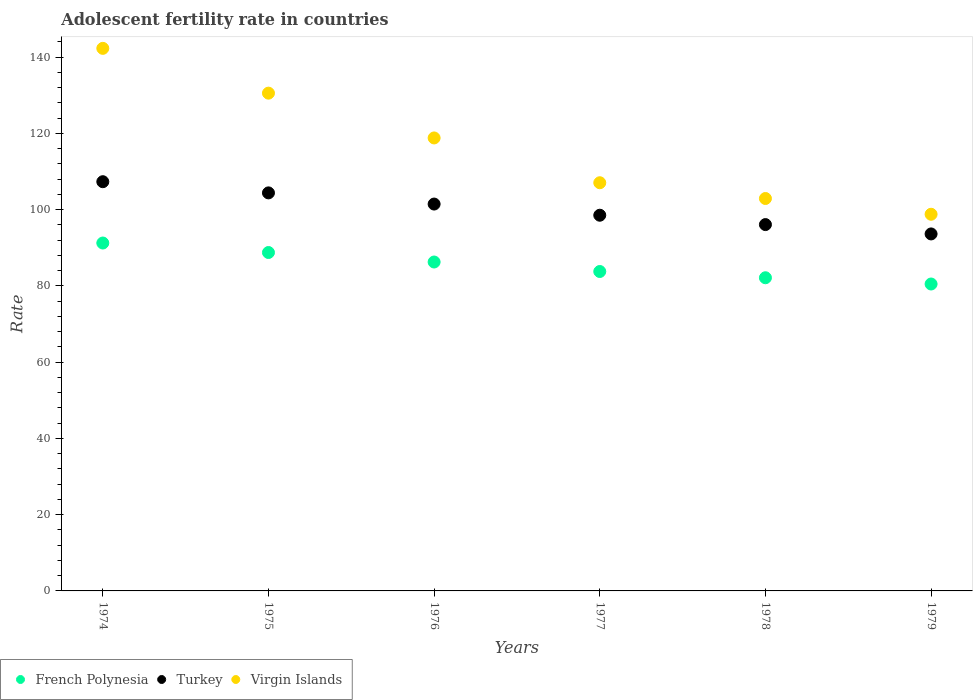What is the adolescent fertility rate in French Polynesia in 1976?
Your answer should be compact. 86.27. Across all years, what is the maximum adolescent fertility rate in French Polynesia?
Keep it short and to the point. 91.26. Across all years, what is the minimum adolescent fertility rate in Virgin Islands?
Provide a short and direct response. 98.8. In which year was the adolescent fertility rate in French Polynesia maximum?
Give a very brief answer. 1974. In which year was the adolescent fertility rate in Turkey minimum?
Keep it short and to the point. 1979. What is the total adolescent fertility rate in French Polynesia in the graph?
Your answer should be very brief. 512.73. What is the difference between the adolescent fertility rate in Turkey in 1975 and that in 1977?
Your answer should be very brief. 5.86. What is the difference between the adolescent fertility rate in French Polynesia in 1979 and the adolescent fertility rate in Turkey in 1977?
Make the answer very short. -18.04. What is the average adolescent fertility rate in French Polynesia per year?
Offer a very short reply. 85.45. In the year 1976, what is the difference between the adolescent fertility rate in Turkey and adolescent fertility rate in French Polynesia?
Give a very brief answer. 15.2. In how many years, is the adolescent fertility rate in Turkey greater than 8?
Offer a very short reply. 6. What is the ratio of the adolescent fertility rate in Virgin Islands in 1975 to that in 1976?
Ensure brevity in your answer.  1.1. Is the adolescent fertility rate in Turkey in 1975 less than that in 1976?
Provide a succinct answer. No. Is the difference between the adolescent fertility rate in Turkey in 1974 and 1975 greater than the difference between the adolescent fertility rate in French Polynesia in 1974 and 1975?
Give a very brief answer. Yes. What is the difference between the highest and the second highest adolescent fertility rate in French Polynesia?
Offer a very short reply. 2.49. What is the difference between the highest and the lowest adolescent fertility rate in Virgin Islands?
Offer a terse response. 43.52. In how many years, is the adolescent fertility rate in Virgin Islands greater than the average adolescent fertility rate in Virgin Islands taken over all years?
Your answer should be very brief. 3. Does the adolescent fertility rate in Virgin Islands monotonically increase over the years?
Your answer should be compact. No. Is the adolescent fertility rate in Turkey strictly greater than the adolescent fertility rate in Virgin Islands over the years?
Provide a succinct answer. No. Is the adolescent fertility rate in Virgin Islands strictly less than the adolescent fertility rate in Turkey over the years?
Make the answer very short. No. How many dotlines are there?
Ensure brevity in your answer.  3. Does the graph contain any zero values?
Your answer should be very brief. No. Where does the legend appear in the graph?
Ensure brevity in your answer.  Bottom left. How many legend labels are there?
Provide a short and direct response. 3. How are the legend labels stacked?
Provide a short and direct response. Horizontal. What is the title of the graph?
Offer a terse response. Adolescent fertility rate in countries. Does "Pacific island small states" appear as one of the legend labels in the graph?
Make the answer very short. No. What is the label or title of the Y-axis?
Give a very brief answer. Rate. What is the Rate of French Polynesia in 1974?
Make the answer very short. 91.26. What is the Rate of Turkey in 1974?
Your answer should be compact. 107.34. What is the Rate of Virgin Islands in 1974?
Keep it short and to the point. 142.32. What is the Rate of French Polynesia in 1975?
Keep it short and to the point. 88.76. What is the Rate of Turkey in 1975?
Your answer should be very brief. 104.41. What is the Rate of Virgin Islands in 1975?
Offer a very short reply. 130.57. What is the Rate of French Polynesia in 1976?
Offer a very short reply. 86.27. What is the Rate of Turkey in 1976?
Give a very brief answer. 101.48. What is the Rate in Virgin Islands in 1976?
Offer a very short reply. 118.82. What is the Rate of French Polynesia in 1977?
Your response must be concise. 83.78. What is the Rate of Turkey in 1977?
Offer a terse response. 98.54. What is the Rate of Virgin Islands in 1977?
Provide a succinct answer. 107.07. What is the Rate in French Polynesia in 1978?
Give a very brief answer. 82.14. What is the Rate of Turkey in 1978?
Give a very brief answer. 96.09. What is the Rate in Virgin Islands in 1978?
Make the answer very short. 102.93. What is the Rate of French Polynesia in 1979?
Your answer should be compact. 80.5. What is the Rate of Turkey in 1979?
Your answer should be very brief. 93.64. What is the Rate in Virgin Islands in 1979?
Your answer should be very brief. 98.8. Across all years, what is the maximum Rate in French Polynesia?
Make the answer very short. 91.26. Across all years, what is the maximum Rate in Turkey?
Make the answer very short. 107.34. Across all years, what is the maximum Rate in Virgin Islands?
Ensure brevity in your answer.  142.32. Across all years, what is the minimum Rate of French Polynesia?
Provide a succinct answer. 80.5. Across all years, what is the minimum Rate of Turkey?
Your answer should be compact. 93.64. Across all years, what is the minimum Rate in Virgin Islands?
Your answer should be very brief. 98.8. What is the total Rate in French Polynesia in the graph?
Make the answer very short. 512.73. What is the total Rate of Turkey in the graph?
Provide a short and direct response. 601.5. What is the total Rate of Virgin Islands in the graph?
Offer a very short reply. 700.5. What is the difference between the Rate of French Polynesia in 1974 and that in 1975?
Offer a very short reply. 2.49. What is the difference between the Rate of Turkey in 1974 and that in 1975?
Offer a terse response. 2.93. What is the difference between the Rate in Virgin Islands in 1974 and that in 1975?
Give a very brief answer. 11.75. What is the difference between the Rate in French Polynesia in 1974 and that in 1976?
Keep it short and to the point. 4.98. What is the difference between the Rate in Turkey in 1974 and that in 1976?
Your answer should be compact. 5.86. What is the difference between the Rate in Virgin Islands in 1974 and that in 1976?
Provide a succinct answer. 23.5. What is the difference between the Rate in French Polynesia in 1974 and that in 1977?
Ensure brevity in your answer.  7.47. What is the difference between the Rate in Turkey in 1974 and that in 1977?
Your answer should be very brief. 8.79. What is the difference between the Rate in Virgin Islands in 1974 and that in 1977?
Your answer should be compact. 35.25. What is the difference between the Rate of French Polynesia in 1974 and that in 1978?
Offer a terse response. 9.11. What is the difference between the Rate of Turkey in 1974 and that in 1978?
Make the answer very short. 11.25. What is the difference between the Rate in Virgin Islands in 1974 and that in 1978?
Your answer should be very brief. 39.38. What is the difference between the Rate of French Polynesia in 1974 and that in 1979?
Provide a succinct answer. 10.75. What is the difference between the Rate of Turkey in 1974 and that in 1979?
Provide a short and direct response. 13.7. What is the difference between the Rate of Virgin Islands in 1974 and that in 1979?
Make the answer very short. 43.52. What is the difference between the Rate in French Polynesia in 1975 and that in 1976?
Make the answer very short. 2.49. What is the difference between the Rate in Turkey in 1975 and that in 1976?
Your answer should be very brief. 2.93. What is the difference between the Rate of Virgin Islands in 1975 and that in 1976?
Your response must be concise. 11.75. What is the difference between the Rate of French Polynesia in 1975 and that in 1977?
Give a very brief answer. 4.98. What is the difference between the Rate of Turkey in 1975 and that in 1977?
Make the answer very short. 5.86. What is the difference between the Rate in Virgin Islands in 1975 and that in 1977?
Your response must be concise. 23.5. What is the difference between the Rate of French Polynesia in 1975 and that in 1978?
Offer a very short reply. 6.62. What is the difference between the Rate in Turkey in 1975 and that in 1978?
Your response must be concise. 8.32. What is the difference between the Rate of Virgin Islands in 1975 and that in 1978?
Your answer should be compact. 27.63. What is the difference between the Rate in French Polynesia in 1975 and that in 1979?
Your answer should be compact. 8.26. What is the difference between the Rate of Turkey in 1975 and that in 1979?
Your response must be concise. 10.77. What is the difference between the Rate in Virgin Islands in 1975 and that in 1979?
Provide a succinct answer. 31.77. What is the difference between the Rate of French Polynesia in 1976 and that in 1977?
Provide a short and direct response. 2.49. What is the difference between the Rate in Turkey in 1976 and that in 1977?
Provide a short and direct response. 2.93. What is the difference between the Rate in Virgin Islands in 1976 and that in 1977?
Your answer should be compact. 11.75. What is the difference between the Rate of French Polynesia in 1976 and that in 1978?
Offer a terse response. 4.13. What is the difference between the Rate in Turkey in 1976 and that in 1978?
Ensure brevity in your answer.  5.38. What is the difference between the Rate of Virgin Islands in 1976 and that in 1978?
Offer a very short reply. 15.88. What is the difference between the Rate of French Polynesia in 1976 and that in 1979?
Provide a succinct answer. 5.77. What is the difference between the Rate of Turkey in 1976 and that in 1979?
Offer a terse response. 7.84. What is the difference between the Rate in Virgin Islands in 1976 and that in 1979?
Provide a short and direct response. 20.02. What is the difference between the Rate in French Polynesia in 1977 and that in 1978?
Provide a short and direct response. 1.64. What is the difference between the Rate of Turkey in 1977 and that in 1978?
Keep it short and to the point. 2.45. What is the difference between the Rate of Virgin Islands in 1977 and that in 1978?
Your answer should be very brief. 4.13. What is the difference between the Rate in French Polynesia in 1977 and that in 1979?
Offer a terse response. 3.28. What is the difference between the Rate in Turkey in 1977 and that in 1979?
Offer a very short reply. 4.9. What is the difference between the Rate in Virgin Islands in 1977 and that in 1979?
Provide a succinct answer. 8.27. What is the difference between the Rate in French Polynesia in 1978 and that in 1979?
Your answer should be very brief. 1.64. What is the difference between the Rate in Turkey in 1978 and that in 1979?
Provide a short and direct response. 2.45. What is the difference between the Rate in Virgin Islands in 1978 and that in 1979?
Your response must be concise. 4.13. What is the difference between the Rate of French Polynesia in 1974 and the Rate of Turkey in 1975?
Make the answer very short. -13.15. What is the difference between the Rate in French Polynesia in 1974 and the Rate in Virgin Islands in 1975?
Your answer should be compact. -39.31. What is the difference between the Rate of Turkey in 1974 and the Rate of Virgin Islands in 1975?
Offer a terse response. -23.23. What is the difference between the Rate of French Polynesia in 1974 and the Rate of Turkey in 1976?
Offer a very short reply. -10.22. What is the difference between the Rate of French Polynesia in 1974 and the Rate of Virgin Islands in 1976?
Your answer should be compact. -27.56. What is the difference between the Rate in Turkey in 1974 and the Rate in Virgin Islands in 1976?
Offer a very short reply. -11.48. What is the difference between the Rate of French Polynesia in 1974 and the Rate of Turkey in 1977?
Offer a terse response. -7.29. What is the difference between the Rate of French Polynesia in 1974 and the Rate of Virgin Islands in 1977?
Keep it short and to the point. -15.81. What is the difference between the Rate in Turkey in 1974 and the Rate in Virgin Islands in 1977?
Your answer should be compact. 0.27. What is the difference between the Rate of French Polynesia in 1974 and the Rate of Turkey in 1978?
Your answer should be very brief. -4.84. What is the difference between the Rate in French Polynesia in 1974 and the Rate in Virgin Islands in 1978?
Offer a terse response. -11.68. What is the difference between the Rate in Turkey in 1974 and the Rate in Virgin Islands in 1978?
Keep it short and to the point. 4.41. What is the difference between the Rate of French Polynesia in 1974 and the Rate of Turkey in 1979?
Your response must be concise. -2.38. What is the difference between the Rate in French Polynesia in 1974 and the Rate in Virgin Islands in 1979?
Make the answer very short. -7.54. What is the difference between the Rate of Turkey in 1974 and the Rate of Virgin Islands in 1979?
Ensure brevity in your answer.  8.54. What is the difference between the Rate of French Polynesia in 1975 and the Rate of Turkey in 1976?
Offer a very short reply. -12.71. What is the difference between the Rate in French Polynesia in 1975 and the Rate in Virgin Islands in 1976?
Ensure brevity in your answer.  -30.05. What is the difference between the Rate in Turkey in 1975 and the Rate in Virgin Islands in 1976?
Offer a very short reply. -14.41. What is the difference between the Rate of French Polynesia in 1975 and the Rate of Turkey in 1977?
Provide a succinct answer. -9.78. What is the difference between the Rate in French Polynesia in 1975 and the Rate in Virgin Islands in 1977?
Make the answer very short. -18.3. What is the difference between the Rate in Turkey in 1975 and the Rate in Virgin Islands in 1977?
Give a very brief answer. -2.66. What is the difference between the Rate in French Polynesia in 1975 and the Rate in Turkey in 1978?
Keep it short and to the point. -7.33. What is the difference between the Rate of French Polynesia in 1975 and the Rate of Virgin Islands in 1978?
Offer a terse response. -14.17. What is the difference between the Rate in Turkey in 1975 and the Rate in Virgin Islands in 1978?
Ensure brevity in your answer.  1.47. What is the difference between the Rate in French Polynesia in 1975 and the Rate in Turkey in 1979?
Your answer should be very brief. -4.87. What is the difference between the Rate of French Polynesia in 1975 and the Rate of Virgin Islands in 1979?
Offer a terse response. -10.03. What is the difference between the Rate in Turkey in 1975 and the Rate in Virgin Islands in 1979?
Keep it short and to the point. 5.61. What is the difference between the Rate of French Polynesia in 1976 and the Rate of Turkey in 1977?
Give a very brief answer. -12.27. What is the difference between the Rate in French Polynesia in 1976 and the Rate in Virgin Islands in 1977?
Offer a terse response. -20.79. What is the difference between the Rate of Turkey in 1976 and the Rate of Virgin Islands in 1977?
Your response must be concise. -5.59. What is the difference between the Rate of French Polynesia in 1976 and the Rate of Turkey in 1978?
Offer a terse response. -9.82. What is the difference between the Rate of French Polynesia in 1976 and the Rate of Virgin Islands in 1978?
Offer a terse response. -16.66. What is the difference between the Rate in Turkey in 1976 and the Rate in Virgin Islands in 1978?
Provide a succinct answer. -1.46. What is the difference between the Rate of French Polynesia in 1976 and the Rate of Turkey in 1979?
Make the answer very short. -7.36. What is the difference between the Rate of French Polynesia in 1976 and the Rate of Virgin Islands in 1979?
Your answer should be compact. -12.52. What is the difference between the Rate in Turkey in 1976 and the Rate in Virgin Islands in 1979?
Offer a terse response. 2.68. What is the difference between the Rate of French Polynesia in 1977 and the Rate of Turkey in 1978?
Your response must be concise. -12.31. What is the difference between the Rate in French Polynesia in 1977 and the Rate in Virgin Islands in 1978?
Give a very brief answer. -19.15. What is the difference between the Rate in Turkey in 1977 and the Rate in Virgin Islands in 1978?
Ensure brevity in your answer.  -4.39. What is the difference between the Rate of French Polynesia in 1977 and the Rate of Turkey in 1979?
Your response must be concise. -9.86. What is the difference between the Rate of French Polynesia in 1977 and the Rate of Virgin Islands in 1979?
Your answer should be compact. -15.01. What is the difference between the Rate in Turkey in 1977 and the Rate in Virgin Islands in 1979?
Your response must be concise. -0.25. What is the difference between the Rate in French Polynesia in 1978 and the Rate in Turkey in 1979?
Your answer should be compact. -11.5. What is the difference between the Rate in French Polynesia in 1978 and the Rate in Virgin Islands in 1979?
Offer a very short reply. -16.65. What is the difference between the Rate in Turkey in 1978 and the Rate in Virgin Islands in 1979?
Ensure brevity in your answer.  -2.71. What is the average Rate in French Polynesia per year?
Your answer should be compact. 85.45. What is the average Rate in Turkey per year?
Ensure brevity in your answer.  100.25. What is the average Rate of Virgin Islands per year?
Give a very brief answer. 116.75. In the year 1974, what is the difference between the Rate of French Polynesia and Rate of Turkey?
Offer a very short reply. -16.08. In the year 1974, what is the difference between the Rate in French Polynesia and Rate in Virgin Islands?
Your answer should be very brief. -51.06. In the year 1974, what is the difference between the Rate in Turkey and Rate in Virgin Islands?
Ensure brevity in your answer.  -34.98. In the year 1975, what is the difference between the Rate in French Polynesia and Rate in Turkey?
Your answer should be very brief. -15.64. In the year 1975, what is the difference between the Rate in French Polynesia and Rate in Virgin Islands?
Keep it short and to the point. -41.8. In the year 1975, what is the difference between the Rate in Turkey and Rate in Virgin Islands?
Your answer should be compact. -26.16. In the year 1976, what is the difference between the Rate of French Polynesia and Rate of Turkey?
Give a very brief answer. -15.2. In the year 1976, what is the difference between the Rate of French Polynesia and Rate of Virgin Islands?
Provide a succinct answer. -32.54. In the year 1976, what is the difference between the Rate of Turkey and Rate of Virgin Islands?
Provide a succinct answer. -17.34. In the year 1977, what is the difference between the Rate of French Polynesia and Rate of Turkey?
Give a very brief answer. -14.76. In the year 1977, what is the difference between the Rate of French Polynesia and Rate of Virgin Islands?
Your response must be concise. -23.28. In the year 1977, what is the difference between the Rate in Turkey and Rate in Virgin Islands?
Offer a very short reply. -8.52. In the year 1978, what is the difference between the Rate of French Polynesia and Rate of Turkey?
Your response must be concise. -13.95. In the year 1978, what is the difference between the Rate in French Polynesia and Rate in Virgin Islands?
Offer a very short reply. -20.79. In the year 1978, what is the difference between the Rate in Turkey and Rate in Virgin Islands?
Ensure brevity in your answer.  -6.84. In the year 1979, what is the difference between the Rate in French Polynesia and Rate in Turkey?
Offer a terse response. -13.14. In the year 1979, what is the difference between the Rate in French Polynesia and Rate in Virgin Islands?
Your answer should be very brief. -18.3. In the year 1979, what is the difference between the Rate of Turkey and Rate of Virgin Islands?
Keep it short and to the point. -5.16. What is the ratio of the Rate of French Polynesia in 1974 to that in 1975?
Offer a terse response. 1.03. What is the ratio of the Rate in Turkey in 1974 to that in 1975?
Offer a very short reply. 1.03. What is the ratio of the Rate of Virgin Islands in 1974 to that in 1975?
Offer a very short reply. 1.09. What is the ratio of the Rate in French Polynesia in 1974 to that in 1976?
Your answer should be compact. 1.06. What is the ratio of the Rate of Turkey in 1974 to that in 1976?
Offer a very short reply. 1.06. What is the ratio of the Rate of Virgin Islands in 1974 to that in 1976?
Offer a very short reply. 1.2. What is the ratio of the Rate in French Polynesia in 1974 to that in 1977?
Offer a terse response. 1.09. What is the ratio of the Rate in Turkey in 1974 to that in 1977?
Ensure brevity in your answer.  1.09. What is the ratio of the Rate of Virgin Islands in 1974 to that in 1977?
Your response must be concise. 1.33. What is the ratio of the Rate in French Polynesia in 1974 to that in 1978?
Keep it short and to the point. 1.11. What is the ratio of the Rate in Turkey in 1974 to that in 1978?
Your answer should be compact. 1.12. What is the ratio of the Rate of Virgin Islands in 1974 to that in 1978?
Make the answer very short. 1.38. What is the ratio of the Rate in French Polynesia in 1974 to that in 1979?
Your answer should be compact. 1.13. What is the ratio of the Rate of Turkey in 1974 to that in 1979?
Your answer should be compact. 1.15. What is the ratio of the Rate in Virgin Islands in 1974 to that in 1979?
Keep it short and to the point. 1.44. What is the ratio of the Rate of French Polynesia in 1975 to that in 1976?
Offer a very short reply. 1.03. What is the ratio of the Rate in Turkey in 1975 to that in 1976?
Give a very brief answer. 1.03. What is the ratio of the Rate in Virgin Islands in 1975 to that in 1976?
Offer a terse response. 1.1. What is the ratio of the Rate in French Polynesia in 1975 to that in 1977?
Keep it short and to the point. 1.06. What is the ratio of the Rate in Turkey in 1975 to that in 1977?
Make the answer very short. 1.06. What is the ratio of the Rate in Virgin Islands in 1975 to that in 1977?
Provide a succinct answer. 1.22. What is the ratio of the Rate in French Polynesia in 1975 to that in 1978?
Offer a terse response. 1.08. What is the ratio of the Rate in Turkey in 1975 to that in 1978?
Offer a terse response. 1.09. What is the ratio of the Rate in Virgin Islands in 1975 to that in 1978?
Provide a succinct answer. 1.27. What is the ratio of the Rate of French Polynesia in 1975 to that in 1979?
Ensure brevity in your answer.  1.1. What is the ratio of the Rate of Turkey in 1975 to that in 1979?
Offer a very short reply. 1.11. What is the ratio of the Rate of Virgin Islands in 1975 to that in 1979?
Offer a terse response. 1.32. What is the ratio of the Rate in French Polynesia in 1976 to that in 1977?
Keep it short and to the point. 1.03. What is the ratio of the Rate in Turkey in 1976 to that in 1977?
Your response must be concise. 1.03. What is the ratio of the Rate in Virgin Islands in 1976 to that in 1977?
Provide a succinct answer. 1.11. What is the ratio of the Rate in French Polynesia in 1976 to that in 1978?
Give a very brief answer. 1.05. What is the ratio of the Rate in Turkey in 1976 to that in 1978?
Provide a short and direct response. 1.06. What is the ratio of the Rate of Virgin Islands in 1976 to that in 1978?
Offer a terse response. 1.15. What is the ratio of the Rate in French Polynesia in 1976 to that in 1979?
Give a very brief answer. 1.07. What is the ratio of the Rate of Turkey in 1976 to that in 1979?
Keep it short and to the point. 1.08. What is the ratio of the Rate in Virgin Islands in 1976 to that in 1979?
Your answer should be compact. 1.2. What is the ratio of the Rate in French Polynesia in 1977 to that in 1978?
Ensure brevity in your answer.  1.02. What is the ratio of the Rate of Turkey in 1977 to that in 1978?
Your answer should be very brief. 1.03. What is the ratio of the Rate of Virgin Islands in 1977 to that in 1978?
Offer a very short reply. 1.04. What is the ratio of the Rate of French Polynesia in 1977 to that in 1979?
Keep it short and to the point. 1.04. What is the ratio of the Rate of Turkey in 1977 to that in 1979?
Provide a short and direct response. 1.05. What is the ratio of the Rate in Virgin Islands in 1977 to that in 1979?
Offer a terse response. 1.08. What is the ratio of the Rate of French Polynesia in 1978 to that in 1979?
Make the answer very short. 1.02. What is the ratio of the Rate in Turkey in 1978 to that in 1979?
Offer a terse response. 1.03. What is the ratio of the Rate in Virgin Islands in 1978 to that in 1979?
Your answer should be very brief. 1.04. What is the difference between the highest and the second highest Rate of French Polynesia?
Provide a succinct answer. 2.49. What is the difference between the highest and the second highest Rate in Turkey?
Ensure brevity in your answer.  2.93. What is the difference between the highest and the second highest Rate of Virgin Islands?
Your answer should be very brief. 11.75. What is the difference between the highest and the lowest Rate in French Polynesia?
Your answer should be very brief. 10.75. What is the difference between the highest and the lowest Rate in Turkey?
Offer a terse response. 13.7. What is the difference between the highest and the lowest Rate in Virgin Islands?
Make the answer very short. 43.52. 